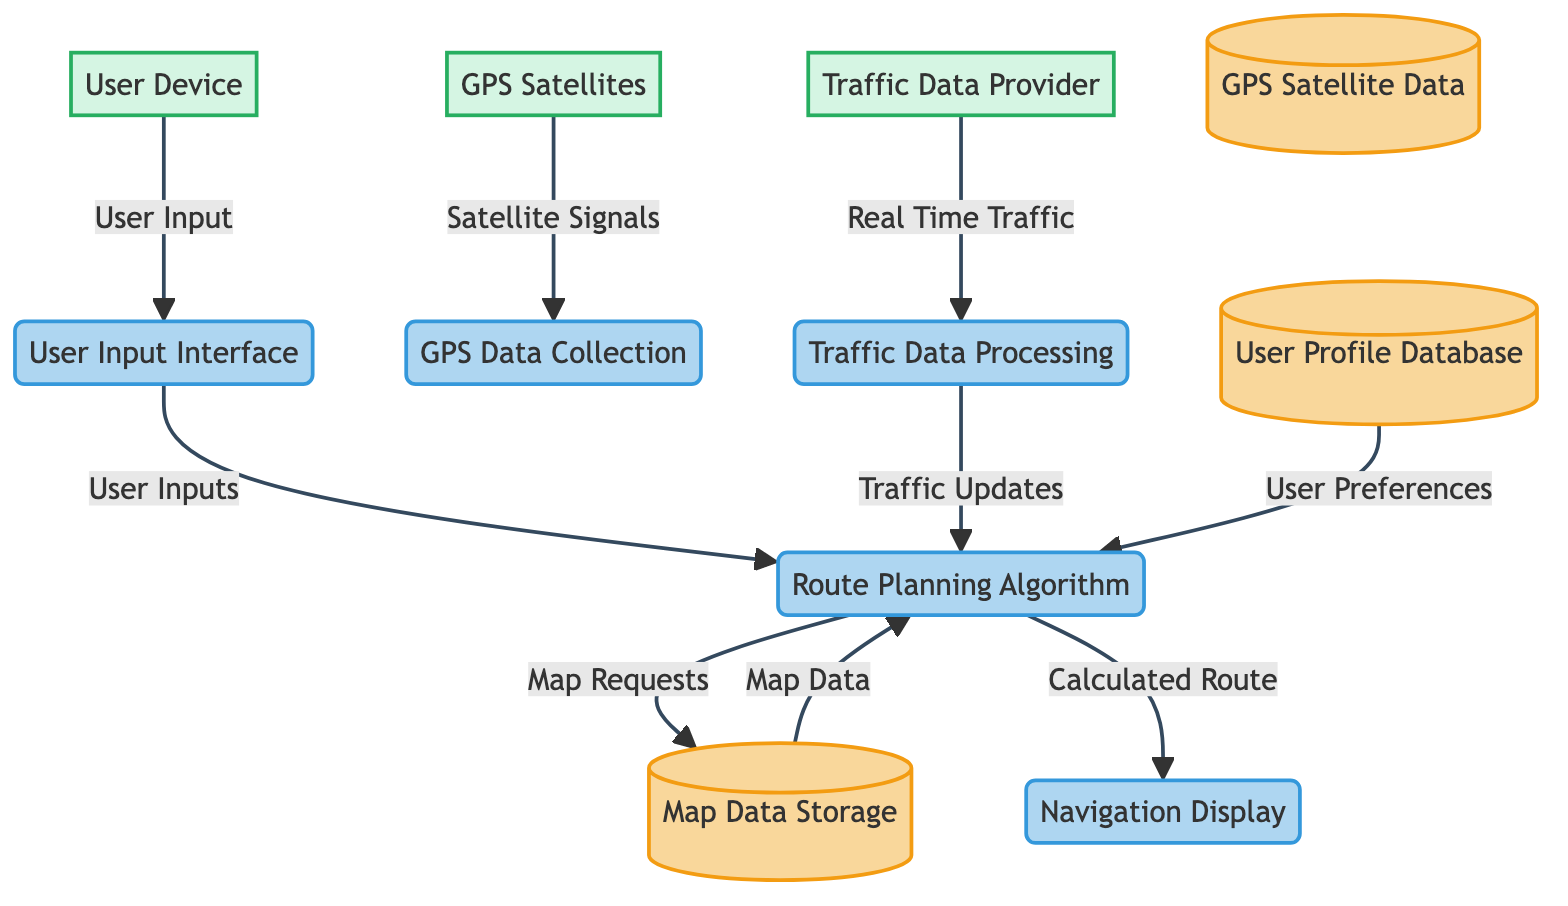What is the name of the process that collects data from GPS satellites? The diagram shows a process labeled "GPS Data Collection" which is responsible for collecting data from GPS satellites. Since this is the only process connected to the GPS satellites in the diagram, it clearly indicates the function being asked about.
Answer: GPS Data Collection How many data stores are present in the diagram? By reviewing the diagram, there are three distinct data stores: "GPS Satellite Data," "User Profile Database," and "Map Data Storage." Counting these, we determine the total number of data stores.
Answer: 3 What type of data flow comes from the Traffic Data Provider? The arrow from the Traffic Data Provider indicates that it supplies "Real Time Traffic" data to the Traffic Data Processing process. Therefore, the data flow type specified by this connection is clearly defined.
Answer: Real Time Traffic Which external entity provides location data? The external entity labeled "GPS Satellites" is specifically indicated as providing location data to the process of GPS Data Collection. This designation helps identify the external source of this data within the navigation system.
Answer: GPS Satellites What does the User Input Interface send to the Route Planning Algorithm? The User Input Interface sends "User Inputs" to the Route Planning Algorithm. This connection depicts the flow of information from user inputs to the routing process, illustrating how user interaction influences navigation calculations.
Answer: User Inputs What is the purpose of the Traffic Data Processing process? The process labeled "Traffic Data Processing" is intended to process real-time traffic data and subsequently update the Route Planning Algorithm with traffic conditions, as indicated by its connections in the diagram. This identifies its role in optimizing navigation based on traffic.
Answer: Process real-time traffic data Which process is the final step before displaying the navigation information? The final step before navigation display is the Route Planning Algorithm, which computes and sends the "Calculated Route" to the Navigation Display process, showing the sequence of operations leading to the visualization of navigation aid for the user.
Answer: Route Planning Algorithm Which data store sends user preferences to the Route Planning Algorithm? The User Profile Database sends "User Preferences" to the Route Planning Algorithm. This indicates that user-specific configurations and preferences are integrated into route planning to personalize navigation services.
Answer: User Profile Database What type of data does the Map Data Storage provide to the Route Planning Algorithm? The connection from Map Data Storage to Route Planning Algorithm carries "Map Data." This indicates the type of information shared between these two components, emphasizing the necessity of geographic information in route calculation.
Answer: Map Data 